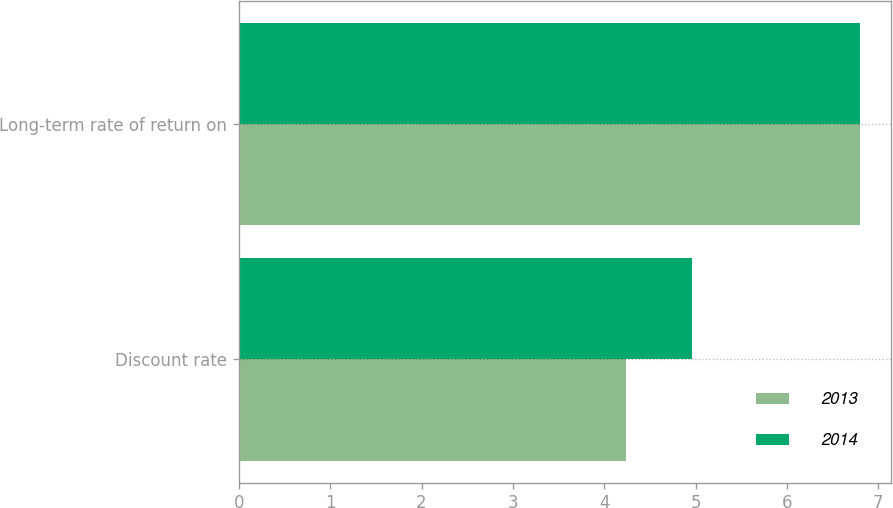Convert chart. <chart><loc_0><loc_0><loc_500><loc_500><stacked_bar_chart><ecel><fcel>Discount rate<fcel>Long-term rate of return on<nl><fcel>2013<fcel>4.24<fcel>6.8<nl><fcel>2014<fcel>4.96<fcel>6.8<nl></chart> 